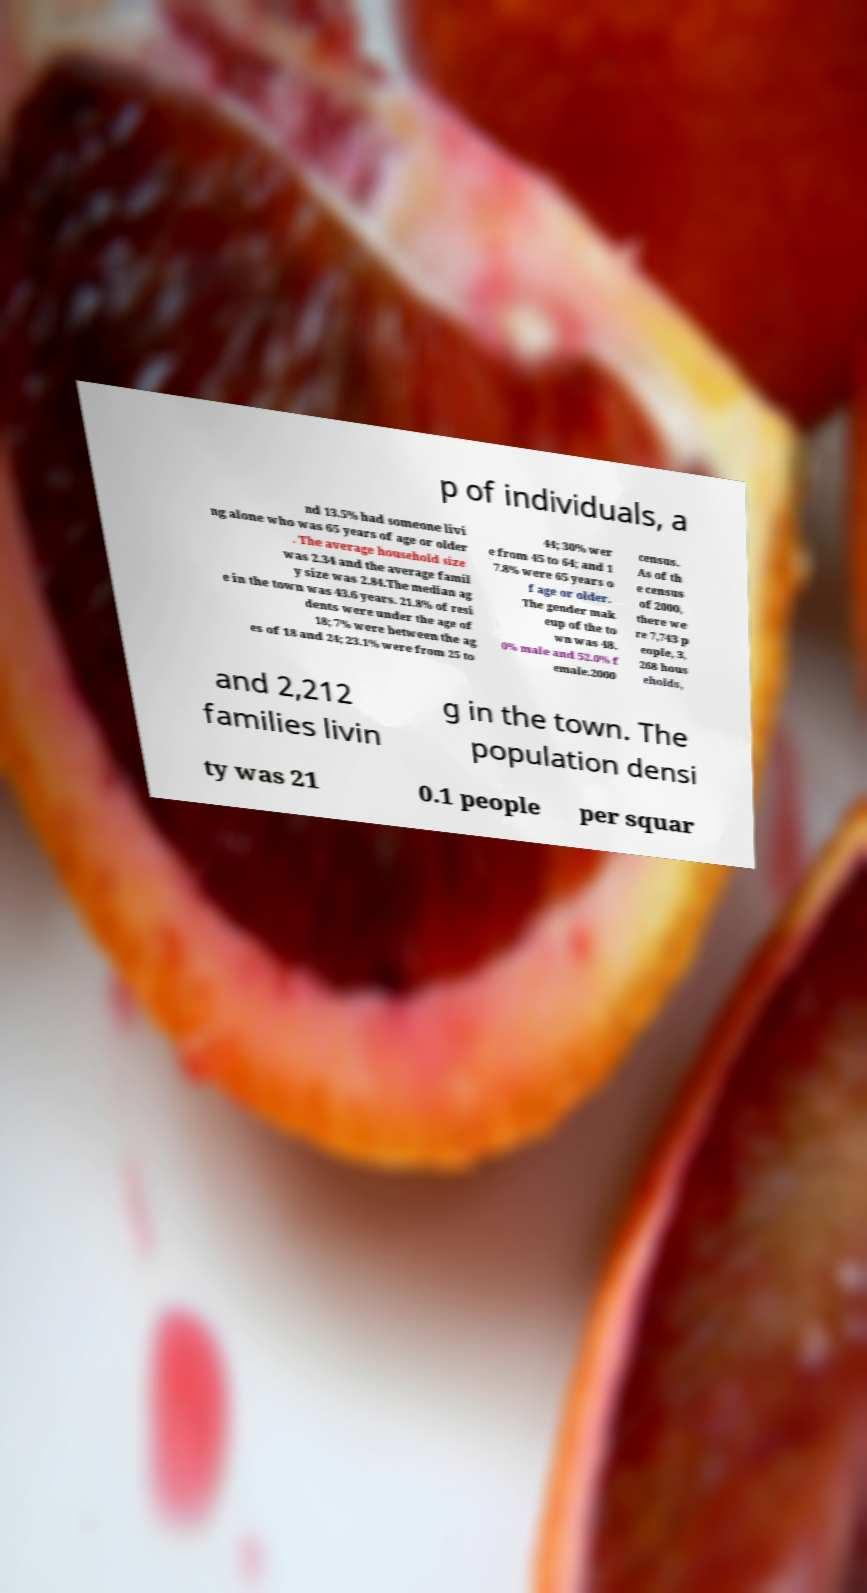Please read and relay the text visible in this image. What does it say? p of individuals, a nd 13.5% had someone livi ng alone who was 65 years of age or older . The average household size was 2.34 and the average famil y size was 2.84.The median ag e in the town was 43.6 years. 21.8% of resi dents were under the age of 18; 7% were between the ag es of 18 and 24; 23.1% were from 25 to 44; 30% wer e from 45 to 64; and 1 7.8% were 65 years o f age or older. The gender mak eup of the to wn was 48. 0% male and 52.0% f emale.2000 census. As of th e census of 2000, there we re 7,743 p eople, 3, 268 hous eholds, and 2,212 families livin g in the town. The population densi ty was 21 0.1 people per squar 